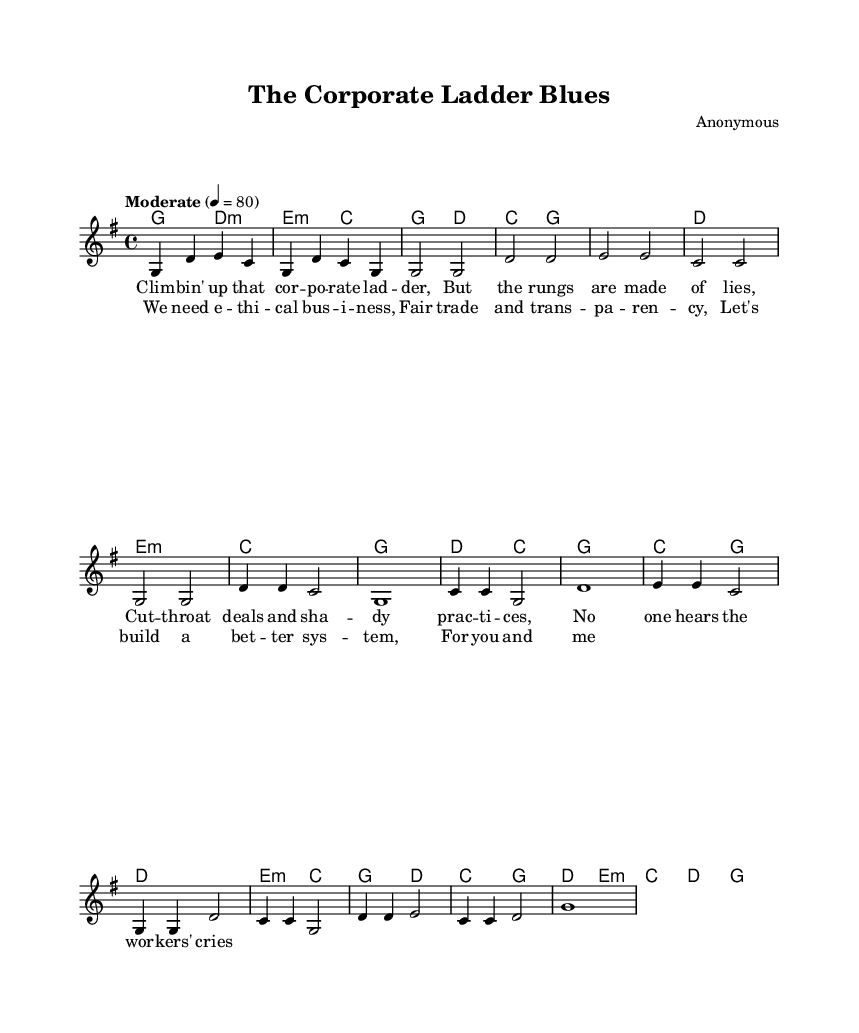What is the key signature of this music? The key signature is G major, which has one sharp (F#). This can be found at the beginning of the staff, indicating the key the piece is written in.
Answer: G major What is the time signature of this music? The time signature is 4/4, which is indicated at the beginning of the score. This means there are four beats in each measure and a quarter note receives one beat.
Answer: 4/4 What is the tempo marking of this music? The tempo marking is "Moderate," with a metronome marking of 80 beats per minute. This is stated at the beginning of the score, indicating the desired speed of the piece.
Answer: Moderate How many measures are in the verse? The verse consists of 8 measures. Each line of the verse corresponds to 4 measures, and there are 2 lines in total shown in the sheet music.
Answer: 8 measures What backing chords are used in the chorus? The chords used in the chorus are C, G, D, E minor. These can be identified by looking at the chord symbols written above the melody in the chorus section.
Answer: C, G, D, E minor How does the structure of this song reflect its folk origins? The song's structure includes simple verses and a repetitive chorus, which are common characteristics of folk music, allowing for easy sing-along and storytelling. This can be inferred from the alternating verse and chorus format typical of folk protest songs.
Answer: Simple verses and repetitive chorus 